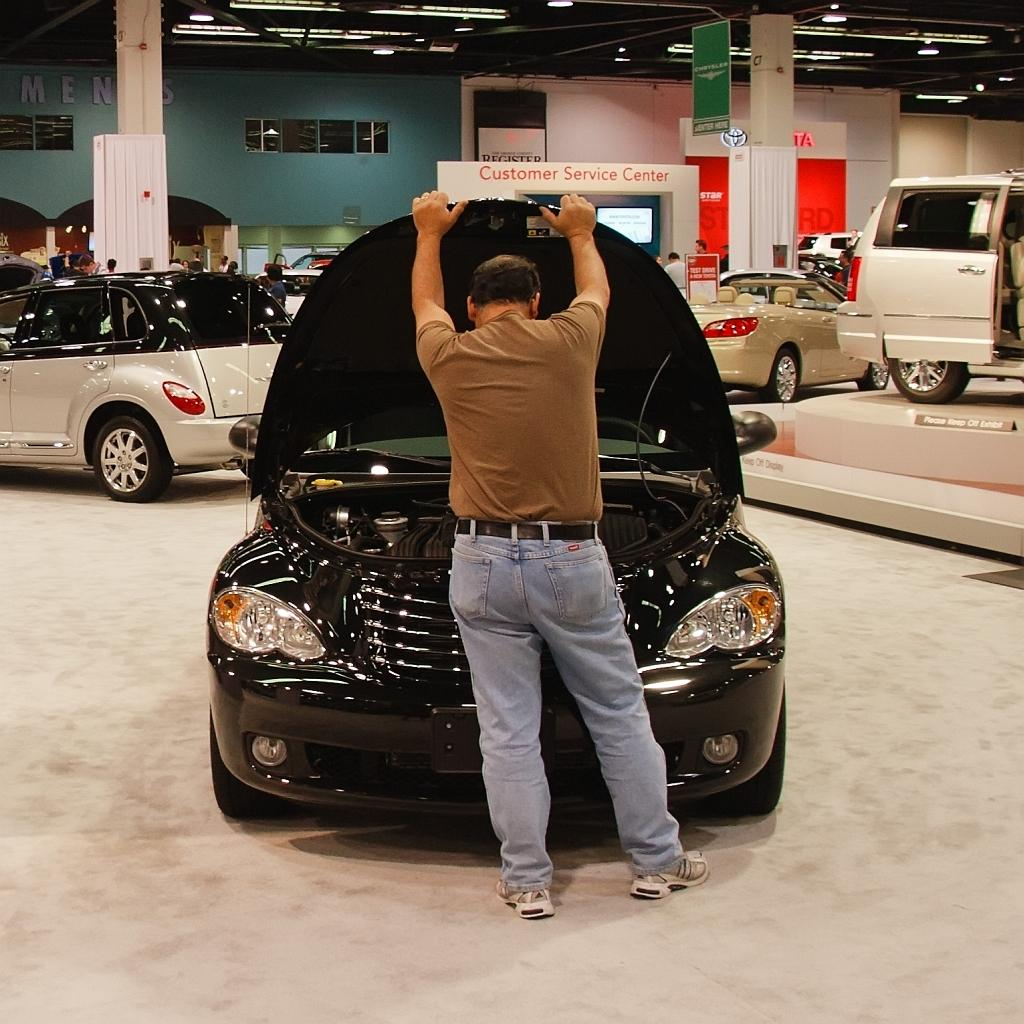What is the main subject of the image? The main subject of the image is cars in a shed. What is the person in the image doing? The person is holding a car hood. What can be seen in the background of the image? There are lights visible in the image. What type of object is present in the image that might be used for displaying information? There is a screen in the image. What is the purpose of the board in the image? The board might be used for writing or displaying information. What type of decorative object is visible in the image? A poster is visible in the image. What type of structural support can be seen in the image? There are pillars in the image. What is the chance of winning a trade in the image? There is no reference to a trade or chance of winning in the image. What type of pump is visible in the image? There is no pump present in the image. 